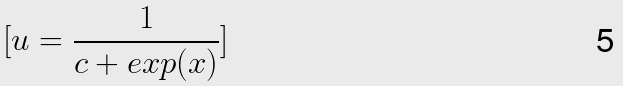Convert formula to latex. <formula><loc_0><loc_0><loc_500><loc_500>[ u = \frac { 1 } { c + e x p ( x ) } ]</formula> 